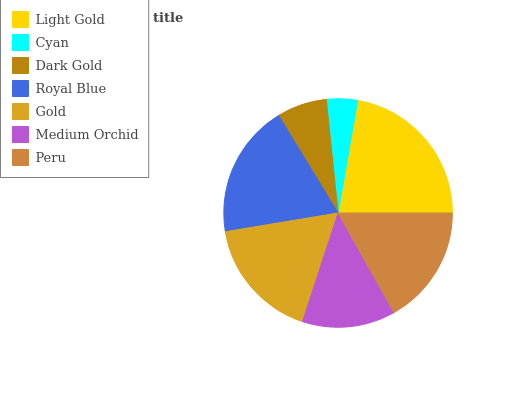Is Cyan the minimum?
Answer yes or no. Yes. Is Light Gold the maximum?
Answer yes or no. Yes. Is Dark Gold the minimum?
Answer yes or no. No. Is Dark Gold the maximum?
Answer yes or no. No. Is Dark Gold greater than Cyan?
Answer yes or no. Yes. Is Cyan less than Dark Gold?
Answer yes or no. Yes. Is Cyan greater than Dark Gold?
Answer yes or no. No. Is Dark Gold less than Cyan?
Answer yes or no. No. Is Peru the high median?
Answer yes or no. Yes. Is Peru the low median?
Answer yes or no. Yes. Is Medium Orchid the high median?
Answer yes or no. No. Is Gold the low median?
Answer yes or no. No. 